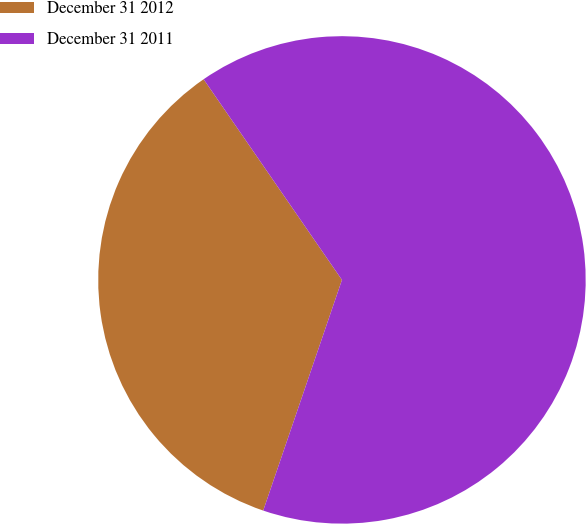Convert chart. <chart><loc_0><loc_0><loc_500><loc_500><pie_chart><fcel>December 31 2012<fcel>December 31 2011<nl><fcel>35.16%<fcel>64.84%<nl></chart> 